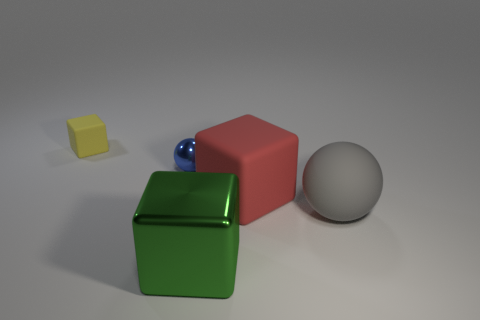There is a matte block in front of the yellow block left of the big red block; what is its size?
Provide a short and direct response. Large. Is there anything else that has the same material as the big gray thing?
Your answer should be compact. Yes. Is the number of small brown blocks greater than the number of big matte things?
Your answer should be compact. No. Do the rubber cube in front of the tiny cube and the rubber object to the left of the red rubber cube have the same color?
Keep it short and to the point. No. Is there a large metal cube in front of the small thing that is to the right of the yellow object?
Keep it short and to the point. Yes. Is the number of big red rubber things that are to the right of the big red thing less than the number of gray things on the left side of the blue shiny object?
Offer a terse response. No. Are the ball in front of the tiny blue thing and the object behind the tiny blue sphere made of the same material?
Provide a short and direct response. Yes. What number of small things are balls or yellow blocks?
Offer a very short reply. 2. The tiny thing that is the same material as the green cube is what shape?
Your answer should be compact. Sphere. Are there fewer green cubes behind the tiny sphere than small yellow things?
Keep it short and to the point. Yes. 